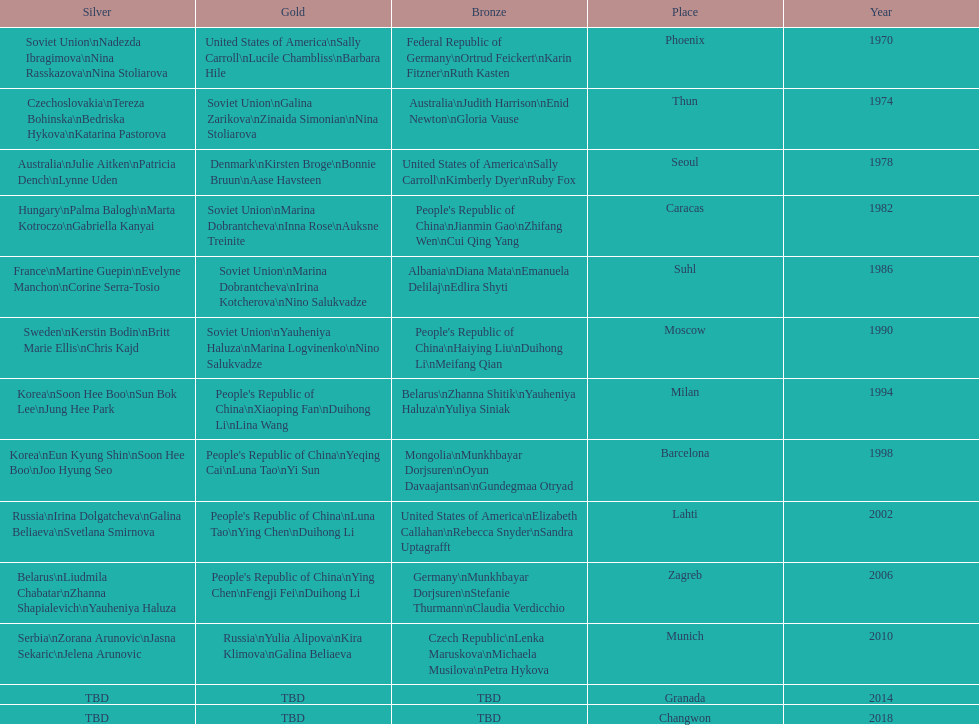What are the total number of times the soviet union is listed under the gold column? 4. 